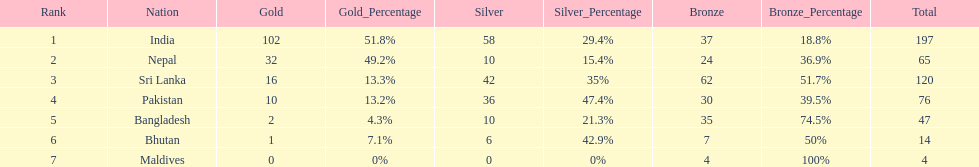How many gold medals did india win? 102. 